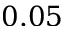Convert formula to latex. <formula><loc_0><loc_0><loc_500><loc_500>0 . 0 5</formula> 